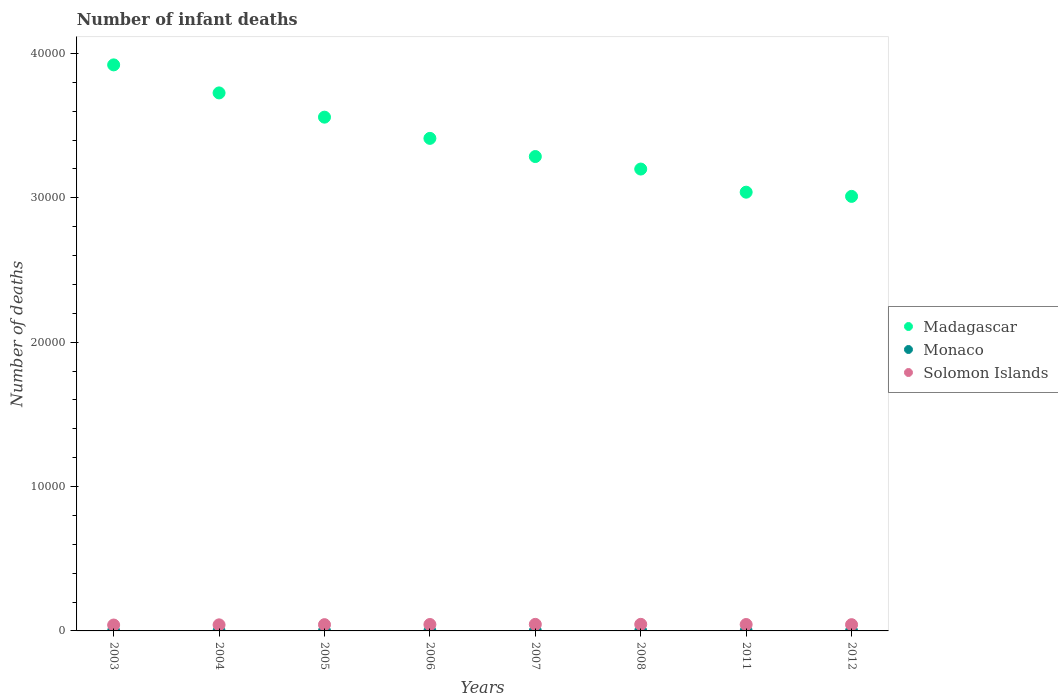Is the number of dotlines equal to the number of legend labels?
Your response must be concise. Yes. What is the number of infant deaths in Monaco in 2003?
Make the answer very short. 1. Across all years, what is the maximum number of infant deaths in Monaco?
Give a very brief answer. 1. Across all years, what is the minimum number of infant deaths in Monaco?
Provide a short and direct response. 1. In which year was the number of infant deaths in Solomon Islands maximum?
Keep it short and to the point. 2008. What is the total number of infant deaths in Solomon Islands in the graph?
Provide a short and direct response. 3495. What is the difference between the number of infant deaths in Madagascar in 2004 and that in 2006?
Provide a short and direct response. 3148. What is the difference between the number of infant deaths in Monaco in 2011 and the number of infant deaths in Madagascar in 2004?
Give a very brief answer. -3.73e+04. In the year 2004, what is the difference between the number of infant deaths in Madagascar and number of infant deaths in Solomon Islands?
Your answer should be very brief. 3.68e+04. What is the ratio of the number of infant deaths in Monaco in 2004 to that in 2008?
Ensure brevity in your answer.  1. Is the difference between the number of infant deaths in Madagascar in 2005 and 2007 greater than the difference between the number of infant deaths in Solomon Islands in 2005 and 2007?
Provide a succinct answer. Yes. What is the difference between the highest and the second highest number of infant deaths in Solomon Islands?
Provide a succinct answer. 2. What is the difference between the highest and the lowest number of infant deaths in Solomon Islands?
Provide a succinct answer. 48. Is the sum of the number of infant deaths in Madagascar in 2004 and 2011 greater than the maximum number of infant deaths in Solomon Islands across all years?
Your answer should be compact. Yes. Is it the case that in every year, the sum of the number of infant deaths in Solomon Islands and number of infant deaths in Madagascar  is greater than the number of infant deaths in Monaco?
Give a very brief answer. Yes. How many years are there in the graph?
Offer a very short reply. 8. What is the difference between two consecutive major ticks on the Y-axis?
Offer a terse response. 10000. Does the graph contain any zero values?
Provide a succinct answer. No. Does the graph contain grids?
Your response must be concise. No. Where does the legend appear in the graph?
Make the answer very short. Center right. What is the title of the graph?
Your response must be concise. Number of infant deaths. What is the label or title of the Y-axis?
Make the answer very short. Number of deaths. What is the Number of deaths of Madagascar in 2003?
Offer a terse response. 3.92e+04. What is the Number of deaths in Monaco in 2003?
Your answer should be compact. 1. What is the Number of deaths in Solomon Islands in 2003?
Ensure brevity in your answer.  408. What is the Number of deaths in Madagascar in 2004?
Offer a terse response. 3.73e+04. What is the Number of deaths in Solomon Islands in 2004?
Your response must be concise. 421. What is the Number of deaths in Madagascar in 2005?
Your answer should be very brief. 3.56e+04. What is the Number of deaths in Monaco in 2005?
Provide a succinct answer. 1. What is the Number of deaths of Solomon Islands in 2005?
Your answer should be very brief. 434. What is the Number of deaths in Madagascar in 2006?
Your answer should be compact. 3.41e+04. What is the Number of deaths in Solomon Islands in 2006?
Keep it short and to the point. 445. What is the Number of deaths in Madagascar in 2007?
Ensure brevity in your answer.  3.29e+04. What is the Number of deaths in Solomon Islands in 2007?
Your answer should be compact. 454. What is the Number of deaths in Madagascar in 2008?
Keep it short and to the point. 3.20e+04. What is the Number of deaths in Monaco in 2008?
Give a very brief answer. 1. What is the Number of deaths of Solomon Islands in 2008?
Your answer should be compact. 456. What is the Number of deaths in Madagascar in 2011?
Offer a very short reply. 3.04e+04. What is the Number of deaths in Monaco in 2011?
Ensure brevity in your answer.  1. What is the Number of deaths in Solomon Islands in 2011?
Your answer should be compact. 444. What is the Number of deaths of Madagascar in 2012?
Give a very brief answer. 3.01e+04. What is the Number of deaths of Monaco in 2012?
Provide a succinct answer. 1. What is the Number of deaths in Solomon Islands in 2012?
Ensure brevity in your answer.  433. Across all years, what is the maximum Number of deaths in Madagascar?
Provide a short and direct response. 3.92e+04. Across all years, what is the maximum Number of deaths of Monaco?
Your answer should be compact. 1. Across all years, what is the maximum Number of deaths in Solomon Islands?
Provide a short and direct response. 456. Across all years, what is the minimum Number of deaths in Madagascar?
Your answer should be very brief. 3.01e+04. Across all years, what is the minimum Number of deaths in Monaco?
Offer a terse response. 1. Across all years, what is the minimum Number of deaths in Solomon Islands?
Offer a very short reply. 408. What is the total Number of deaths of Madagascar in the graph?
Give a very brief answer. 2.71e+05. What is the total Number of deaths in Solomon Islands in the graph?
Give a very brief answer. 3495. What is the difference between the Number of deaths in Madagascar in 2003 and that in 2004?
Ensure brevity in your answer.  1942. What is the difference between the Number of deaths of Monaco in 2003 and that in 2004?
Your response must be concise. 0. What is the difference between the Number of deaths in Solomon Islands in 2003 and that in 2004?
Keep it short and to the point. -13. What is the difference between the Number of deaths of Madagascar in 2003 and that in 2005?
Offer a very short reply. 3621. What is the difference between the Number of deaths of Monaco in 2003 and that in 2005?
Ensure brevity in your answer.  0. What is the difference between the Number of deaths in Solomon Islands in 2003 and that in 2005?
Your answer should be very brief. -26. What is the difference between the Number of deaths of Madagascar in 2003 and that in 2006?
Offer a terse response. 5090. What is the difference between the Number of deaths in Monaco in 2003 and that in 2006?
Your answer should be very brief. 0. What is the difference between the Number of deaths of Solomon Islands in 2003 and that in 2006?
Your answer should be very brief. -37. What is the difference between the Number of deaths in Madagascar in 2003 and that in 2007?
Your answer should be very brief. 6349. What is the difference between the Number of deaths of Solomon Islands in 2003 and that in 2007?
Give a very brief answer. -46. What is the difference between the Number of deaths in Madagascar in 2003 and that in 2008?
Your response must be concise. 7215. What is the difference between the Number of deaths in Solomon Islands in 2003 and that in 2008?
Provide a short and direct response. -48. What is the difference between the Number of deaths in Madagascar in 2003 and that in 2011?
Your answer should be compact. 8817. What is the difference between the Number of deaths in Monaco in 2003 and that in 2011?
Your response must be concise. 0. What is the difference between the Number of deaths in Solomon Islands in 2003 and that in 2011?
Give a very brief answer. -36. What is the difference between the Number of deaths in Madagascar in 2003 and that in 2012?
Make the answer very short. 9108. What is the difference between the Number of deaths of Solomon Islands in 2003 and that in 2012?
Offer a very short reply. -25. What is the difference between the Number of deaths of Madagascar in 2004 and that in 2005?
Give a very brief answer. 1679. What is the difference between the Number of deaths in Monaco in 2004 and that in 2005?
Your response must be concise. 0. What is the difference between the Number of deaths of Madagascar in 2004 and that in 2006?
Your answer should be very brief. 3148. What is the difference between the Number of deaths of Monaco in 2004 and that in 2006?
Your answer should be compact. 0. What is the difference between the Number of deaths of Solomon Islands in 2004 and that in 2006?
Your response must be concise. -24. What is the difference between the Number of deaths of Madagascar in 2004 and that in 2007?
Ensure brevity in your answer.  4407. What is the difference between the Number of deaths of Solomon Islands in 2004 and that in 2007?
Your answer should be compact. -33. What is the difference between the Number of deaths in Madagascar in 2004 and that in 2008?
Offer a terse response. 5273. What is the difference between the Number of deaths in Solomon Islands in 2004 and that in 2008?
Offer a very short reply. -35. What is the difference between the Number of deaths in Madagascar in 2004 and that in 2011?
Ensure brevity in your answer.  6875. What is the difference between the Number of deaths in Solomon Islands in 2004 and that in 2011?
Provide a succinct answer. -23. What is the difference between the Number of deaths of Madagascar in 2004 and that in 2012?
Offer a terse response. 7166. What is the difference between the Number of deaths in Madagascar in 2005 and that in 2006?
Keep it short and to the point. 1469. What is the difference between the Number of deaths in Madagascar in 2005 and that in 2007?
Offer a terse response. 2728. What is the difference between the Number of deaths of Madagascar in 2005 and that in 2008?
Offer a very short reply. 3594. What is the difference between the Number of deaths in Monaco in 2005 and that in 2008?
Your answer should be very brief. 0. What is the difference between the Number of deaths of Madagascar in 2005 and that in 2011?
Your answer should be compact. 5196. What is the difference between the Number of deaths in Monaco in 2005 and that in 2011?
Keep it short and to the point. 0. What is the difference between the Number of deaths of Solomon Islands in 2005 and that in 2011?
Offer a terse response. -10. What is the difference between the Number of deaths of Madagascar in 2005 and that in 2012?
Your answer should be very brief. 5487. What is the difference between the Number of deaths in Madagascar in 2006 and that in 2007?
Your answer should be very brief. 1259. What is the difference between the Number of deaths of Madagascar in 2006 and that in 2008?
Make the answer very short. 2125. What is the difference between the Number of deaths in Solomon Islands in 2006 and that in 2008?
Ensure brevity in your answer.  -11. What is the difference between the Number of deaths of Madagascar in 2006 and that in 2011?
Your answer should be very brief. 3727. What is the difference between the Number of deaths in Solomon Islands in 2006 and that in 2011?
Ensure brevity in your answer.  1. What is the difference between the Number of deaths of Madagascar in 2006 and that in 2012?
Make the answer very short. 4018. What is the difference between the Number of deaths in Solomon Islands in 2006 and that in 2012?
Ensure brevity in your answer.  12. What is the difference between the Number of deaths of Madagascar in 2007 and that in 2008?
Offer a terse response. 866. What is the difference between the Number of deaths of Monaco in 2007 and that in 2008?
Your response must be concise. 0. What is the difference between the Number of deaths in Solomon Islands in 2007 and that in 2008?
Offer a terse response. -2. What is the difference between the Number of deaths of Madagascar in 2007 and that in 2011?
Provide a short and direct response. 2468. What is the difference between the Number of deaths of Monaco in 2007 and that in 2011?
Provide a short and direct response. 0. What is the difference between the Number of deaths in Madagascar in 2007 and that in 2012?
Offer a terse response. 2759. What is the difference between the Number of deaths of Monaco in 2007 and that in 2012?
Offer a very short reply. 0. What is the difference between the Number of deaths of Madagascar in 2008 and that in 2011?
Provide a succinct answer. 1602. What is the difference between the Number of deaths of Solomon Islands in 2008 and that in 2011?
Your answer should be very brief. 12. What is the difference between the Number of deaths in Madagascar in 2008 and that in 2012?
Make the answer very short. 1893. What is the difference between the Number of deaths of Monaco in 2008 and that in 2012?
Make the answer very short. 0. What is the difference between the Number of deaths in Madagascar in 2011 and that in 2012?
Your answer should be very brief. 291. What is the difference between the Number of deaths of Madagascar in 2003 and the Number of deaths of Monaco in 2004?
Provide a short and direct response. 3.92e+04. What is the difference between the Number of deaths of Madagascar in 2003 and the Number of deaths of Solomon Islands in 2004?
Your answer should be compact. 3.88e+04. What is the difference between the Number of deaths in Monaco in 2003 and the Number of deaths in Solomon Islands in 2004?
Your answer should be very brief. -420. What is the difference between the Number of deaths in Madagascar in 2003 and the Number of deaths in Monaco in 2005?
Make the answer very short. 3.92e+04. What is the difference between the Number of deaths of Madagascar in 2003 and the Number of deaths of Solomon Islands in 2005?
Ensure brevity in your answer.  3.88e+04. What is the difference between the Number of deaths in Monaco in 2003 and the Number of deaths in Solomon Islands in 2005?
Your answer should be compact. -433. What is the difference between the Number of deaths of Madagascar in 2003 and the Number of deaths of Monaco in 2006?
Your answer should be very brief. 3.92e+04. What is the difference between the Number of deaths of Madagascar in 2003 and the Number of deaths of Solomon Islands in 2006?
Make the answer very short. 3.88e+04. What is the difference between the Number of deaths of Monaco in 2003 and the Number of deaths of Solomon Islands in 2006?
Keep it short and to the point. -444. What is the difference between the Number of deaths of Madagascar in 2003 and the Number of deaths of Monaco in 2007?
Provide a succinct answer. 3.92e+04. What is the difference between the Number of deaths of Madagascar in 2003 and the Number of deaths of Solomon Islands in 2007?
Offer a terse response. 3.88e+04. What is the difference between the Number of deaths of Monaco in 2003 and the Number of deaths of Solomon Islands in 2007?
Offer a very short reply. -453. What is the difference between the Number of deaths in Madagascar in 2003 and the Number of deaths in Monaco in 2008?
Provide a succinct answer. 3.92e+04. What is the difference between the Number of deaths in Madagascar in 2003 and the Number of deaths in Solomon Islands in 2008?
Offer a terse response. 3.87e+04. What is the difference between the Number of deaths in Monaco in 2003 and the Number of deaths in Solomon Islands in 2008?
Offer a terse response. -455. What is the difference between the Number of deaths of Madagascar in 2003 and the Number of deaths of Monaco in 2011?
Ensure brevity in your answer.  3.92e+04. What is the difference between the Number of deaths of Madagascar in 2003 and the Number of deaths of Solomon Islands in 2011?
Provide a short and direct response. 3.88e+04. What is the difference between the Number of deaths in Monaco in 2003 and the Number of deaths in Solomon Islands in 2011?
Provide a short and direct response. -443. What is the difference between the Number of deaths of Madagascar in 2003 and the Number of deaths of Monaco in 2012?
Your answer should be compact. 3.92e+04. What is the difference between the Number of deaths in Madagascar in 2003 and the Number of deaths in Solomon Islands in 2012?
Provide a succinct answer. 3.88e+04. What is the difference between the Number of deaths in Monaco in 2003 and the Number of deaths in Solomon Islands in 2012?
Provide a succinct answer. -432. What is the difference between the Number of deaths of Madagascar in 2004 and the Number of deaths of Monaco in 2005?
Keep it short and to the point. 3.73e+04. What is the difference between the Number of deaths of Madagascar in 2004 and the Number of deaths of Solomon Islands in 2005?
Keep it short and to the point. 3.68e+04. What is the difference between the Number of deaths of Monaco in 2004 and the Number of deaths of Solomon Islands in 2005?
Keep it short and to the point. -433. What is the difference between the Number of deaths in Madagascar in 2004 and the Number of deaths in Monaco in 2006?
Your answer should be compact. 3.73e+04. What is the difference between the Number of deaths in Madagascar in 2004 and the Number of deaths in Solomon Islands in 2006?
Offer a very short reply. 3.68e+04. What is the difference between the Number of deaths of Monaco in 2004 and the Number of deaths of Solomon Islands in 2006?
Provide a short and direct response. -444. What is the difference between the Number of deaths of Madagascar in 2004 and the Number of deaths of Monaco in 2007?
Your answer should be compact. 3.73e+04. What is the difference between the Number of deaths in Madagascar in 2004 and the Number of deaths in Solomon Islands in 2007?
Offer a very short reply. 3.68e+04. What is the difference between the Number of deaths of Monaco in 2004 and the Number of deaths of Solomon Islands in 2007?
Your response must be concise. -453. What is the difference between the Number of deaths in Madagascar in 2004 and the Number of deaths in Monaco in 2008?
Provide a short and direct response. 3.73e+04. What is the difference between the Number of deaths of Madagascar in 2004 and the Number of deaths of Solomon Islands in 2008?
Keep it short and to the point. 3.68e+04. What is the difference between the Number of deaths in Monaco in 2004 and the Number of deaths in Solomon Islands in 2008?
Keep it short and to the point. -455. What is the difference between the Number of deaths in Madagascar in 2004 and the Number of deaths in Monaco in 2011?
Provide a succinct answer. 3.73e+04. What is the difference between the Number of deaths of Madagascar in 2004 and the Number of deaths of Solomon Islands in 2011?
Your answer should be very brief. 3.68e+04. What is the difference between the Number of deaths of Monaco in 2004 and the Number of deaths of Solomon Islands in 2011?
Provide a succinct answer. -443. What is the difference between the Number of deaths in Madagascar in 2004 and the Number of deaths in Monaco in 2012?
Your response must be concise. 3.73e+04. What is the difference between the Number of deaths in Madagascar in 2004 and the Number of deaths in Solomon Islands in 2012?
Your response must be concise. 3.68e+04. What is the difference between the Number of deaths of Monaco in 2004 and the Number of deaths of Solomon Islands in 2012?
Keep it short and to the point. -432. What is the difference between the Number of deaths of Madagascar in 2005 and the Number of deaths of Monaco in 2006?
Make the answer very short. 3.56e+04. What is the difference between the Number of deaths of Madagascar in 2005 and the Number of deaths of Solomon Islands in 2006?
Provide a short and direct response. 3.51e+04. What is the difference between the Number of deaths of Monaco in 2005 and the Number of deaths of Solomon Islands in 2006?
Provide a short and direct response. -444. What is the difference between the Number of deaths in Madagascar in 2005 and the Number of deaths in Monaco in 2007?
Your answer should be very brief. 3.56e+04. What is the difference between the Number of deaths in Madagascar in 2005 and the Number of deaths in Solomon Islands in 2007?
Provide a succinct answer. 3.51e+04. What is the difference between the Number of deaths in Monaco in 2005 and the Number of deaths in Solomon Islands in 2007?
Offer a terse response. -453. What is the difference between the Number of deaths in Madagascar in 2005 and the Number of deaths in Monaco in 2008?
Make the answer very short. 3.56e+04. What is the difference between the Number of deaths of Madagascar in 2005 and the Number of deaths of Solomon Islands in 2008?
Your answer should be very brief. 3.51e+04. What is the difference between the Number of deaths in Monaco in 2005 and the Number of deaths in Solomon Islands in 2008?
Your answer should be very brief. -455. What is the difference between the Number of deaths of Madagascar in 2005 and the Number of deaths of Monaco in 2011?
Give a very brief answer. 3.56e+04. What is the difference between the Number of deaths of Madagascar in 2005 and the Number of deaths of Solomon Islands in 2011?
Your response must be concise. 3.51e+04. What is the difference between the Number of deaths in Monaco in 2005 and the Number of deaths in Solomon Islands in 2011?
Offer a terse response. -443. What is the difference between the Number of deaths of Madagascar in 2005 and the Number of deaths of Monaco in 2012?
Keep it short and to the point. 3.56e+04. What is the difference between the Number of deaths in Madagascar in 2005 and the Number of deaths in Solomon Islands in 2012?
Ensure brevity in your answer.  3.52e+04. What is the difference between the Number of deaths of Monaco in 2005 and the Number of deaths of Solomon Islands in 2012?
Provide a succinct answer. -432. What is the difference between the Number of deaths in Madagascar in 2006 and the Number of deaths in Monaco in 2007?
Provide a succinct answer. 3.41e+04. What is the difference between the Number of deaths of Madagascar in 2006 and the Number of deaths of Solomon Islands in 2007?
Provide a short and direct response. 3.37e+04. What is the difference between the Number of deaths in Monaco in 2006 and the Number of deaths in Solomon Islands in 2007?
Your response must be concise. -453. What is the difference between the Number of deaths of Madagascar in 2006 and the Number of deaths of Monaco in 2008?
Keep it short and to the point. 3.41e+04. What is the difference between the Number of deaths of Madagascar in 2006 and the Number of deaths of Solomon Islands in 2008?
Your response must be concise. 3.37e+04. What is the difference between the Number of deaths of Monaco in 2006 and the Number of deaths of Solomon Islands in 2008?
Make the answer very short. -455. What is the difference between the Number of deaths of Madagascar in 2006 and the Number of deaths of Monaco in 2011?
Your response must be concise. 3.41e+04. What is the difference between the Number of deaths of Madagascar in 2006 and the Number of deaths of Solomon Islands in 2011?
Ensure brevity in your answer.  3.37e+04. What is the difference between the Number of deaths of Monaco in 2006 and the Number of deaths of Solomon Islands in 2011?
Provide a short and direct response. -443. What is the difference between the Number of deaths of Madagascar in 2006 and the Number of deaths of Monaco in 2012?
Provide a short and direct response. 3.41e+04. What is the difference between the Number of deaths of Madagascar in 2006 and the Number of deaths of Solomon Islands in 2012?
Provide a succinct answer. 3.37e+04. What is the difference between the Number of deaths in Monaco in 2006 and the Number of deaths in Solomon Islands in 2012?
Your answer should be compact. -432. What is the difference between the Number of deaths of Madagascar in 2007 and the Number of deaths of Monaco in 2008?
Offer a terse response. 3.29e+04. What is the difference between the Number of deaths of Madagascar in 2007 and the Number of deaths of Solomon Islands in 2008?
Offer a terse response. 3.24e+04. What is the difference between the Number of deaths of Monaco in 2007 and the Number of deaths of Solomon Islands in 2008?
Keep it short and to the point. -455. What is the difference between the Number of deaths in Madagascar in 2007 and the Number of deaths in Monaco in 2011?
Give a very brief answer. 3.29e+04. What is the difference between the Number of deaths in Madagascar in 2007 and the Number of deaths in Solomon Islands in 2011?
Offer a terse response. 3.24e+04. What is the difference between the Number of deaths in Monaco in 2007 and the Number of deaths in Solomon Islands in 2011?
Your response must be concise. -443. What is the difference between the Number of deaths in Madagascar in 2007 and the Number of deaths in Monaco in 2012?
Offer a very short reply. 3.29e+04. What is the difference between the Number of deaths of Madagascar in 2007 and the Number of deaths of Solomon Islands in 2012?
Provide a short and direct response. 3.24e+04. What is the difference between the Number of deaths in Monaco in 2007 and the Number of deaths in Solomon Islands in 2012?
Your answer should be very brief. -432. What is the difference between the Number of deaths in Madagascar in 2008 and the Number of deaths in Monaco in 2011?
Offer a very short reply. 3.20e+04. What is the difference between the Number of deaths in Madagascar in 2008 and the Number of deaths in Solomon Islands in 2011?
Your answer should be compact. 3.15e+04. What is the difference between the Number of deaths in Monaco in 2008 and the Number of deaths in Solomon Islands in 2011?
Provide a succinct answer. -443. What is the difference between the Number of deaths in Madagascar in 2008 and the Number of deaths in Monaco in 2012?
Make the answer very short. 3.20e+04. What is the difference between the Number of deaths in Madagascar in 2008 and the Number of deaths in Solomon Islands in 2012?
Your answer should be compact. 3.16e+04. What is the difference between the Number of deaths of Monaco in 2008 and the Number of deaths of Solomon Islands in 2012?
Offer a very short reply. -432. What is the difference between the Number of deaths of Madagascar in 2011 and the Number of deaths of Monaco in 2012?
Your answer should be very brief. 3.04e+04. What is the difference between the Number of deaths of Madagascar in 2011 and the Number of deaths of Solomon Islands in 2012?
Offer a terse response. 3.00e+04. What is the difference between the Number of deaths of Monaco in 2011 and the Number of deaths of Solomon Islands in 2012?
Your response must be concise. -432. What is the average Number of deaths in Madagascar per year?
Offer a terse response. 3.39e+04. What is the average Number of deaths of Monaco per year?
Your response must be concise. 1. What is the average Number of deaths in Solomon Islands per year?
Keep it short and to the point. 436.88. In the year 2003, what is the difference between the Number of deaths of Madagascar and Number of deaths of Monaco?
Keep it short and to the point. 3.92e+04. In the year 2003, what is the difference between the Number of deaths of Madagascar and Number of deaths of Solomon Islands?
Provide a short and direct response. 3.88e+04. In the year 2003, what is the difference between the Number of deaths in Monaco and Number of deaths in Solomon Islands?
Offer a terse response. -407. In the year 2004, what is the difference between the Number of deaths of Madagascar and Number of deaths of Monaco?
Make the answer very short. 3.73e+04. In the year 2004, what is the difference between the Number of deaths of Madagascar and Number of deaths of Solomon Islands?
Offer a very short reply. 3.68e+04. In the year 2004, what is the difference between the Number of deaths in Monaco and Number of deaths in Solomon Islands?
Make the answer very short. -420. In the year 2005, what is the difference between the Number of deaths in Madagascar and Number of deaths in Monaco?
Offer a very short reply. 3.56e+04. In the year 2005, what is the difference between the Number of deaths in Madagascar and Number of deaths in Solomon Islands?
Keep it short and to the point. 3.52e+04. In the year 2005, what is the difference between the Number of deaths of Monaco and Number of deaths of Solomon Islands?
Provide a short and direct response. -433. In the year 2006, what is the difference between the Number of deaths of Madagascar and Number of deaths of Monaco?
Your response must be concise. 3.41e+04. In the year 2006, what is the difference between the Number of deaths in Madagascar and Number of deaths in Solomon Islands?
Offer a very short reply. 3.37e+04. In the year 2006, what is the difference between the Number of deaths of Monaco and Number of deaths of Solomon Islands?
Give a very brief answer. -444. In the year 2007, what is the difference between the Number of deaths in Madagascar and Number of deaths in Monaco?
Ensure brevity in your answer.  3.29e+04. In the year 2007, what is the difference between the Number of deaths of Madagascar and Number of deaths of Solomon Islands?
Your answer should be very brief. 3.24e+04. In the year 2007, what is the difference between the Number of deaths of Monaco and Number of deaths of Solomon Islands?
Provide a succinct answer. -453. In the year 2008, what is the difference between the Number of deaths in Madagascar and Number of deaths in Monaco?
Keep it short and to the point. 3.20e+04. In the year 2008, what is the difference between the Number of deaths of Madagascar and Number of deaths of Solomon Islands?
Keep it short and to the point. 3.15e+04. In the year 2008, what is the difference between the Number of deaths of Monaco and Number of deaths of Solomon Islands?
Make the answer very short. -455. In the year 2011, what is the difference between the Number of deaths of Madagascar and Number of deaths of Monaco?
Offer a terse response. 3.04e+04. In the year 2011, what is the difference between the Number of deaths in Madagascar and Number of deaths in Solomon Islands?
Ensure brevity in your answer.  2.99e+04. In the year 2011, what is the difference between the Number of deaths of Monaco and Number of deaths of Solomon Islands?
Keep it short and to the point. -443. In the year 2012, what is the difference between the Number of deaths of Madagascar and Number of deaths of Monaco?
Provide a succinct answer. 3.01e+04. In the year 2012, what is the difference between the Number of deaths of Madagascar and Number of deaths of Solomon Islands?
Give a very brief answer. 2.97e+04. In the year 2012, what is the difference between the Number of deaths in Monaco and Number of deaths in Solomon Islands?
Make the answer very short. -432. What is the ratio of the Number of deaths in Madagascar in 2003 to that in 2004?
Make the answer very short. 1.05. What is the ratio of the Number of deaths in Monaco in 2003 to that in 2004?
Your answer should be very brief. 1. What is the ratio of the Number of deaths in Solomon Islands in 2003 to that in 2004?
Offer a very short reply. 0.97. What is the ratio of the Number of deaths of Madagascar in 2003 to that in 2005?
Your response must be concise. 1.1. What is the ratio of the Number of deaths of Monaco in 2003 to that in 2005?
Offer a terse response. 1. What is the ratio of the Number of deaths of Solomon Islands in 2003 to that in 2005?
Provide a succinct answer. 0.94. What is the ratio of the Number of deaths in Madagascar in 2003 to that in 2006?
Your answer should be compact. 1.15. What is the ratio of the Number of deaths in Monaco in 2003 to that in 2006?
Provide a short and direct response. 1. What is the ratio of the Number of deaths of Solomon Islands in 2003 to that in 2006?
Provide a short and direct response. 0.92. What is the ratio of the Number of deaths of Madagascar in 2003 to that in 2007?
Provide a succinct answer. 1.19. What is the ratio of the Number of deaths of Monaco in 2003 to that in 2007?
Make the answer very short. 1. What is the ratio of the Number of deaths in Solomon Islands in 2003 to that in 2007?
Provide a short and direct response. 0.9. What is the ratio of the Number of deaths of Madagascar in 2003 to that in 2008?
Make the answer very short. 1.23. What is the ratio of the Number of deaths in Solomon Islands in 2003 to that in 2008?
Your response must be concise. 0.89. What is the ratio of the Number of deaths of Madagascar in 2003 to that in 2011?
Make the answer very short. 1.29. What is the ratio of the Number of deaths of Monaco in 2003 to that in 2011?
Provide a succinct answer. 1. What is the ratio of the Number of deaths in Solomon Islands in 2003 to that in 2011?
Make the answer very short. 0.92. What is the ratio of the Number of deaths of Madagascar in 2003 to that in 2012?
Your answer should be very brief. 1.3. What is the ratio of the Number of deaths in Solomon Islands in 2003 to that in 2012?
Your response must be concise. 0.94. What is the ratio of the Number of deaths of Madagascar in 2004 to that in 2005?
Ensure brevity in your answer.  1.05. What is the ratio of the Number of deaths in Solomon Islands in 2004 to that in 2005?
Your answer should be very brief. 0.97. What is the ratio of the Number of deaths of Madagascar in 2004 to that in 2006?
Give a very brief answer. 1.09. What is the ratio of the Number of deaths of Monaco in 2004 to that in 2006?
Ensure brevity in your answer.  1. What is the ratio of the Number of deaths of Solomon Islands in 2004 to that in 2006?
Keep it short and to the point. 0.95. What is the ratio of the Number of deaths in Madagascar in 2004 to that in 2007?
Provide a succinct answer. 1.13. What is the ratio of the Number of deaths of Solomon Islands in 2004 to that in 2007?
Give a very brief answer. 0.93. What is the ratio of the Number of deaths in Madagascar in 2004 to that in 2008?
Give a very brief answer. 1.16. What is the ratio of the Number of deaths in Monaco in 2004 to that in 2008?
Your answer should be compact. 1. What is the ratio of the Number of deaths in Solomon Islands in 2004 to that in 2008?
Provide a short and direct response. 0.92. What is the ratio of the Number of deaths of Madagascar in 2004 to that in 2011?
Keep it short and to the point. 1.23. What is the ratio of the Number of deaths of Monaco in 2004 to that in 2011?
Ensure brevity in your answer.  1. What is the ratio of the Number of deaths in Solomon Islands in 2004 to that in 2011?
Offer a very short reply. 0.95. What is the ratio of the Number of deaths in Madagascar in 2004 to that in 2012?
Your answer should be very brief. 1.24. What is the ratio of the Number of deaths of Monaco in 2004 to that in 2012?
Keep it short and to the point. 1. What is the ratio of the Number of deaths of Solomon Islands in 2004 to that in 2012?
Your answer should be compact. 0.97. What is the ratio of the Number of deaths of Madagascar in 2005 to that in 2006?
Ensure brevity in your answer.  1.04. What is the ratio of the Number of deaths in Solomon Islands in 2005 to that in 2006?
Your answer should be compact. 0.98. What is the ratio of the Number of deaths of Madagascar in 2005 to that in 2007?
Offer a terse response. 1.08. What is the ratio of the Number of deaths of Monaco in 2005 to that in 2007?
Ensure brevity in your answer.  1. What is the ratio of the Number of deaths of Solomon Islands in 2005 to that in 2007?
Your answer should be compact. 0.96. What is the ratio of the Number of deaths of Madagascar in 2005 to that in 2008?
Your response must be concise. 1.11. What is the ratio of the Number of deaths in Solomon Islands in 2005 to that in 2008?
Provide a short and direct response. 0.95. What is the ratio of the Number of deaths of Madagascar in 2005 to that in 2011?
Your response must be concise. 1.17. What is the ratio of the Number of deaths in Solomon Islands in 2005 to that in 2011?
Offer a very short reply. 0.98. What is the ratio of the Number of deaths of Madagascar in 2005 to that in 2012?
Offer a terse response. 1.18. What is the ratio of the Number of deaths in Madagascar in 2006 to that in 2007?
Your response must be concise. 1.04. What is the ratio of the Number of deaths in Solomon Islands in 2006 to that in 2007?
Give a very brief answer. 0.98. What is the ratio of the Number of deaths of Madagascar in 2006 to that in 2008?
Provide a short and direct response. 1.07. What is the ratio of the Number of deaths of Solomon Islands in 2006 to that in 2008?
Your answer should be very brief. 0.98. What is the ratio of the Number of deaths in Madagascar in 2006 to that in 2011?
Your answer should be very brief. 1.12. What is the ratio of the Number of deaths in Solomon Islands in 2006 to that in 2011?
Offer a very short reply. 1. What is the ratio of the Number of deaths of Madagascar in 2006 to that in 2012?
Provide a short and direct response. 1.13. What is the ratio of the Number of deaths in Solomon Islands in 2006 to that in 2012?
Keep it short and to the point. 1.03. What is the ratio of the Number of deaths in Madagascar in 2007 to that in 2008?
Your answer should be very brief. 1.03. What is the ratio of the Number of deaths in Madagascar in 2007 to that in 2011?
Give a very brief answer. 1.08. What is the ratio of the Number of deaths in Solomon Islands in 2007 to that in 2011?
Offer a terse response. 1.02. What is the ratio of the Number of deaths of Madagascar in 2007 to that in 2012?
Offer a very short reply. 1.09. What is the ratio of the Number of deaths in Solomon Islands in 2007 to that in 2012?
Make the answer very short. 1.05. What is the ratio of the Number of deaths in Madagascar in 2008 to that in 2011?
Your response must be concise. 1.05. What is the ratio of the Number of deaths of Solomon Islands in 2008 to that in 2011?
Keep it short and to the point. 1.03. What is the ratio of the Number of deaths in Madagascar in 2008 to that in 2012?
Keep it short and to the point. 1.06. What is the ratio of the Number of deaths in Monaco in 2008 to that in 2012?
Your answer should be compact. 1. What is the ratio of the Number of deaths in Solomon Islands in 2008 to that in 2012?
Provide a succinct answer. 1.05. What is the ratio of the Number of deaths in Madagascar in 2011 to that in 2012?
Your response must be concise. 1.01. What is the ratio of the Number of deaths in Solomon Islands in 2011 to that in 2012?
Offer a terse response. 1.03. What is the difference between the highest and the second highest Number of deaths of Madagascar?
Your response must be concise. 1942. What is the difference between the highest and the lowest Number of deaths in Madagascar?
Ensure brevity in your answer.  9108. 